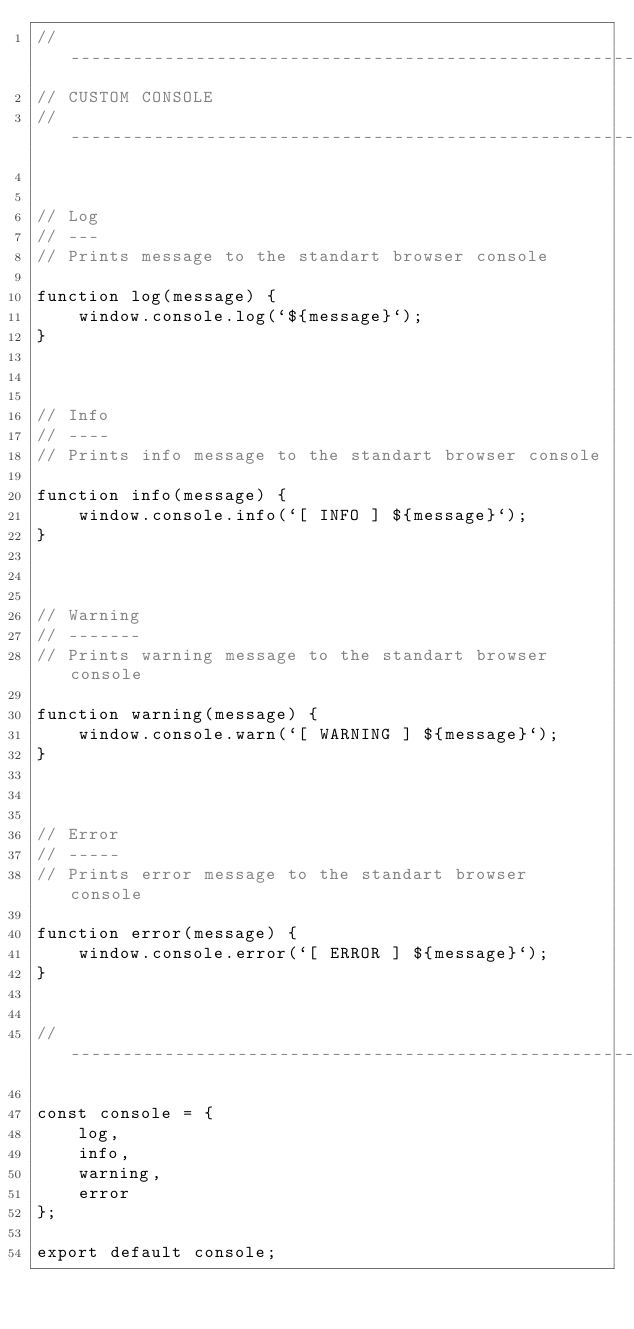<code> <loc_0><loc_0><loc_500><loc_500><_JavaScript_>// -----------------------------------------------------------------------------
// CUSTOM CONSOLE
// -----------------------------------------------------------------------------


// Log
// ---
// Prints message to the standart browser console

function log(message) {
    window.console.log(`${message}`);
}



// Info
// ----
// Prints info message to the standart browser console

function info(message) {
    window.console.info(`[ INFO ] ${message}`);
}



// Warning
// -------
// Prints warning message to the standart browser console

function warning(message) {
    window.console.warn(`[ WARNING ] ${message}`);
}



// Error
// -----
// Prints error message to the standart browser console

function error(message) {
    window.console.error(`[ ERROR ] ${message}`);
}


// -----------------------------------------------------------------------------

const console = {
    log,
    info,
    warning,
    error
};

export default console;

</code> 